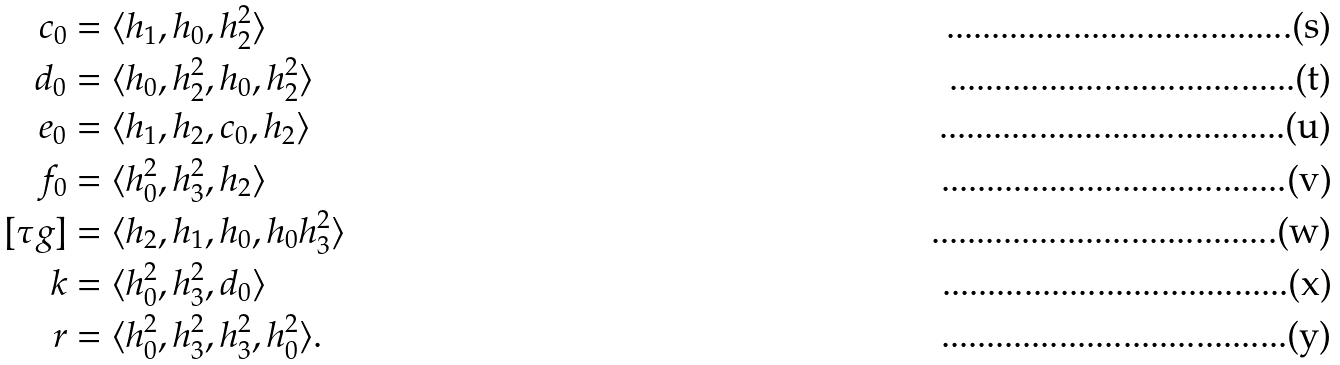<formula> <loc_0><loc_0><loc_500><loc_500>c _ { 0 } & = \langle h _ { 1 } , h _ { 0 } , h _ { 2 } ^ { 2 } \rangle \\ d _ { 0 } & = \langle h _ { 0 } , h _ { 2 } ^ { 2 } , h _ { 0 } , h _ { 2 } ^ { 2 } \rangle \\ e _ { 0 } & = \langle h _ { 1 } , h _ { 2 } , c _ { 0 } , h _ { 2 } \rangle \\ f _ { 0 } & = \langle h _ { 0 } ^ { 2 } , h _ { 3 } ^ { 2 } , h _ { 2 } \rangle \\ [ \tau g ] & = \langle h _ { 2 } , h _ { 1 } , h _ { 0 } , h _ { 0 } h _ { 3 } ^ { 2 } \rangle \\ k & = \langle h _ { 0 } ^ { 2 } , h _ { 3 } ^ { 2 } , d _ { 0 } \rangle \\ r & = \langle h _ { 0 } ^ { 2 } , h _ { 3 } ^ { 2 } , h _ { 3 } ^ { 2 } , h _ { 0 } ^ { 2 } \rangle .</formula> 